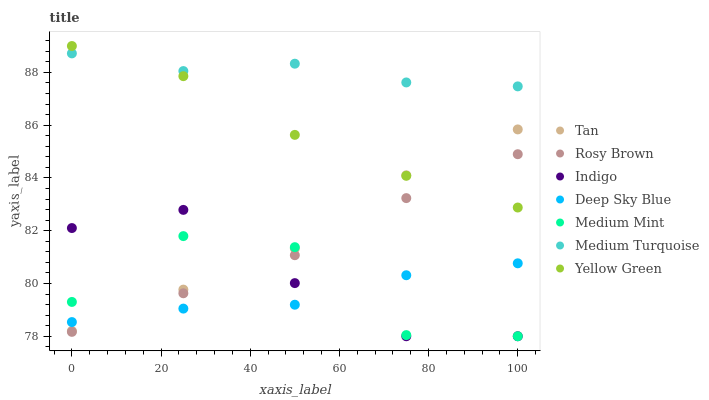Does Deep Sky Blue have the minimum area under the curve?
Answer yes or no. Yes. Does Medium Turquoise have the maximum area under the curve?
Answer yes or no. Yes. Does Indigo have the minimum area under the curve?
Answer yes or no. No. Does Indigo have the maximum area under the curve?
Answer yes or no. No. Is Rosy Brown the smoothest?
Answer yes or no. Yes. Is Medium Mint the roughest?
Answer yes or no. Yes. Is Indigo the smoothest?
Answer yes or no. No. Is Indigo the roughest?
Answer yes or no. No. Does Medium Mint have the lowest value?
Answer yes or no. Yes. Does Deep Sky Blue have the lowest value?
Answer yes or no. No. Does Yellow Green have the highest value?
Answer yes or no. Yes. Does Indigo have the highest value?
Answer yes or no. No. Is Rosy Brown less than Tan?
Answer yes or no. Yes. Is Tan greater than Rosy Brown?
Answer yes or no. Yes. Does Yellow Green intersect Tan?
Answer yes or no. Yes. Is Yellow Green less than Tan?
Answer yes or no. No. Is Yellow Green greater than Tan?
Answer yes or no. No. Does Rosy Brown intersect Tan?
Answer yes or no. No. 